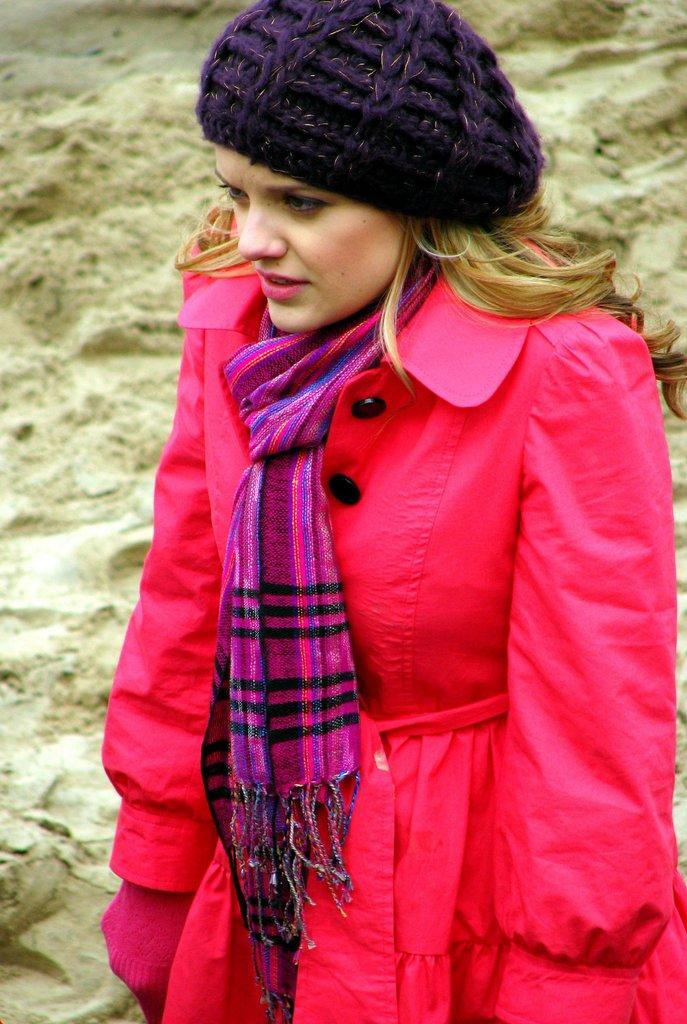Who is the main subject in the picture? There is a woman in the middle of the picture. What is the woman wearing on her upper body? The woman is wearing a pink jacket. What is the woman wearing around her neck? The woman is wearing a pink scarf. What is the woman wearing on her head? The woman is wearing a blue cap. What type of terrain is visible behind the woman? There is sand visible behind the woman. Can you tell me how many sheep are standing next to the woman in the image? There are no sheep present in the image; the main subject is a woman wearing a pink jacket, pink scarf, and blue cap, with sand visible behind her. 